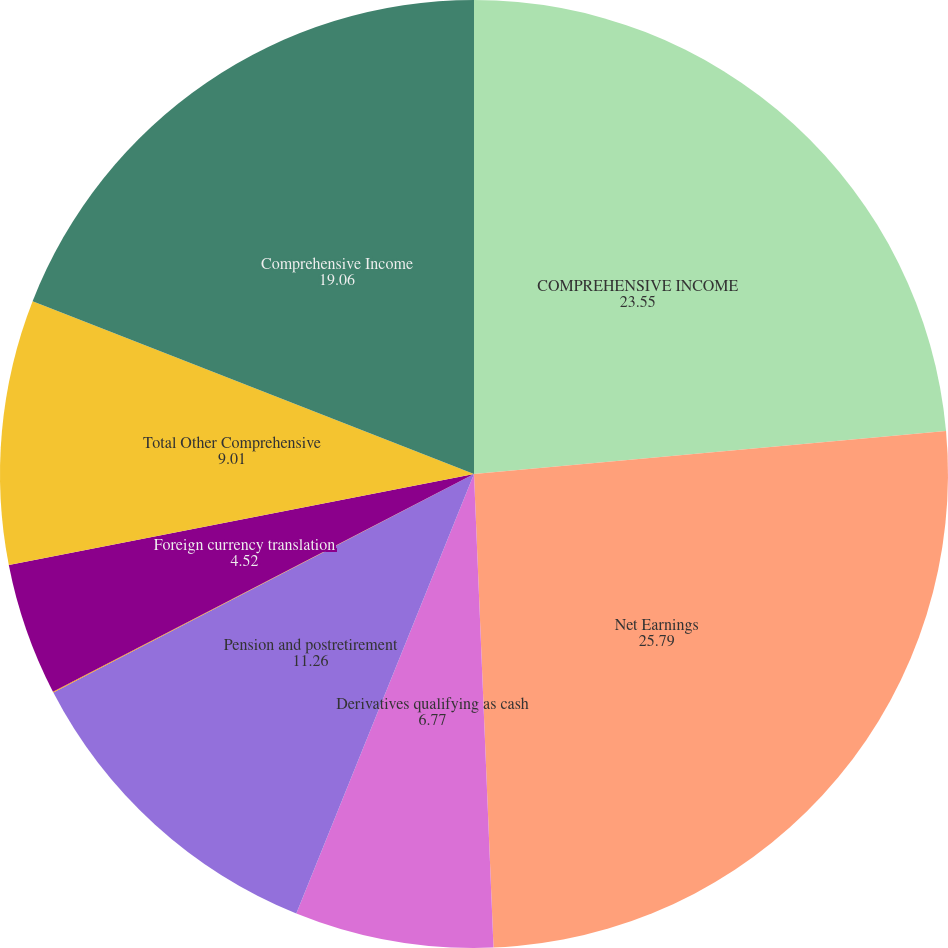Convert chart. <chart><loc_0><loc_0><loc_500><loc_500><pie_chart><fcel>COMPREHENSIVE INCOME<fcel>Net Earnings<fcel>Derivatives qualifying as cash<fcel>Pension and postretirement<fcel>Available-for-sale securities<fcel>Foreign currency translation<fcel>Total Other Comprehensive<fcel>Comprehensive Income<nl><fcel>23.55%<fcel>25.79%<fcel>6.77%<fcel>11.26%<fcel>0.03%<fcel>4.52%<fcel>9.01%<fcel>19.06%<nl></chart> 